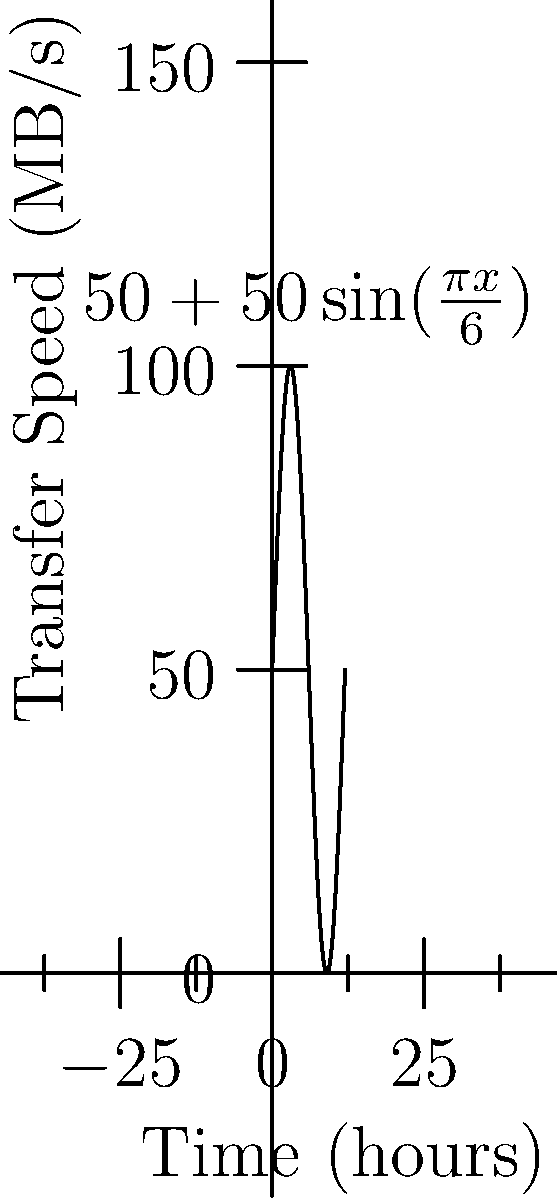As the developer of a file-sharing platform, you're analyzing the data transfer speed over a 12-hour period. The graph shows the transfer speed in MB/s as a function of time in hours, given by the equation $f(t) = 50 + 50\sin(\frac{\pi t}{6})$. Calculate the total amount of data transferred during this 12-hour period. To find the total amount of data transferred, we need to integrate the transfer speed function over the given time period. Here's how we do it:

1) The total data transferred is the area under the curve, which we can find using definite integration:

   $$\text{Total Data} = \int_0^{12} f(t) dt = \int_0^{12} (50 + 50\sin(\frac{\pi t}{6})) dt$$

2) Let's integrate this step by step:
   
   $$\int_0^{12} (50 + 50\sin(\frac{\pi t}{6})) dt = \int_0^{12} 50 dt + \int_0^{12} 50\sin(\frac{\pi t}{6}) dt$$

3) For the first part:
   
   $$\int_0^{12} 50 dt = 50t \bigg|_0^{12} = 600$$

4) For the second part, we use the substitution $u = \frac{\pi t}{6}$, so $du = \frac{\pi}{6} dt$ and $dt = \frac{6}{\pi} du$:

   $$\int_0^{12} 50\sin(\frac{\pi t}{6}) dt = \frac{300}{\pi} \int_0^{2\pi} \sin(u) du = \frac{300}{\pi} [-\cos(u)]_0^{2\pi} = 0$$

5) Adding the results from steps 3 and 4:

   $$\text{Total Data} = 600 + 0 = 600$$

Therefore, the total amount of data transferred is 600 MB-hours, or equivalently, 2160 GB.
Answer: 2160 GB 